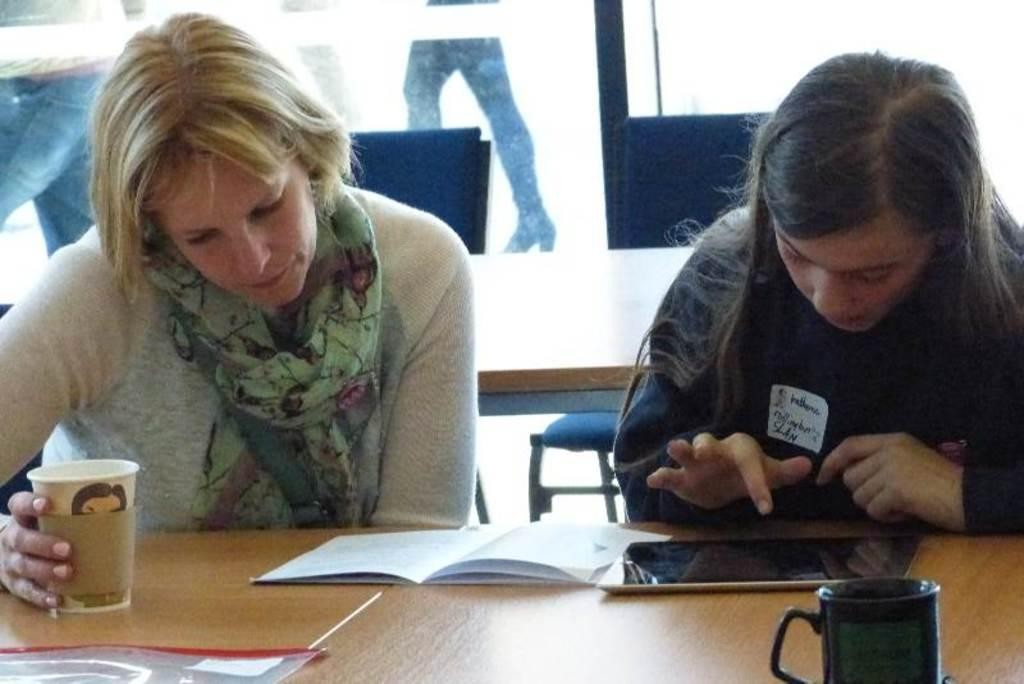How many women are in the image? There are two women in the image. What are the women doing in the image? One woman is playing with a mobile, and the other woman is reading a book. Are the women sitting or standing in the image? Both women are sitting on chairs in the image. What is the woman reading a book holding in her hand? The woman reading a book is holding a glass in her hand. Can you see any doors in the image? There is no mention of a door in the image, so it cannot be confirmed if one is present. Are there any nests visible in the image? There is no mention of a nest in the image, so it cannot be confirmed if one is present. 